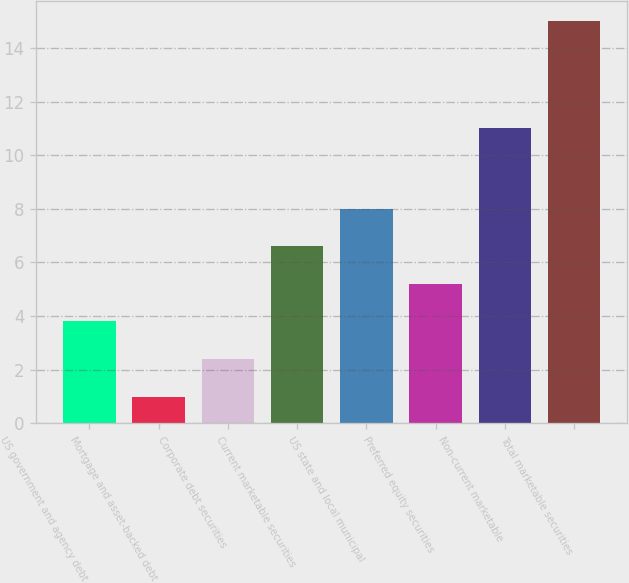Convert chart to OTSL. <chart><loc_0><loc_0><loc_500><loc_500><bar_chart><fcel>US government and agency debt<fcel>Mortgage and asset-backed debt<fcel>Corporate debt securities<fcel>Current marketable securities<fcel>US state and local municipal<fcel>Preferred equity securities<fcel>Non-current marketable<fcel>Total marketable securities<nl><fcel>3.8<fcel>1<fcel>2.4<fcel>6.6<fcel>8<fcel>5.2<fcel>11<fcel>15<nl></chart> 